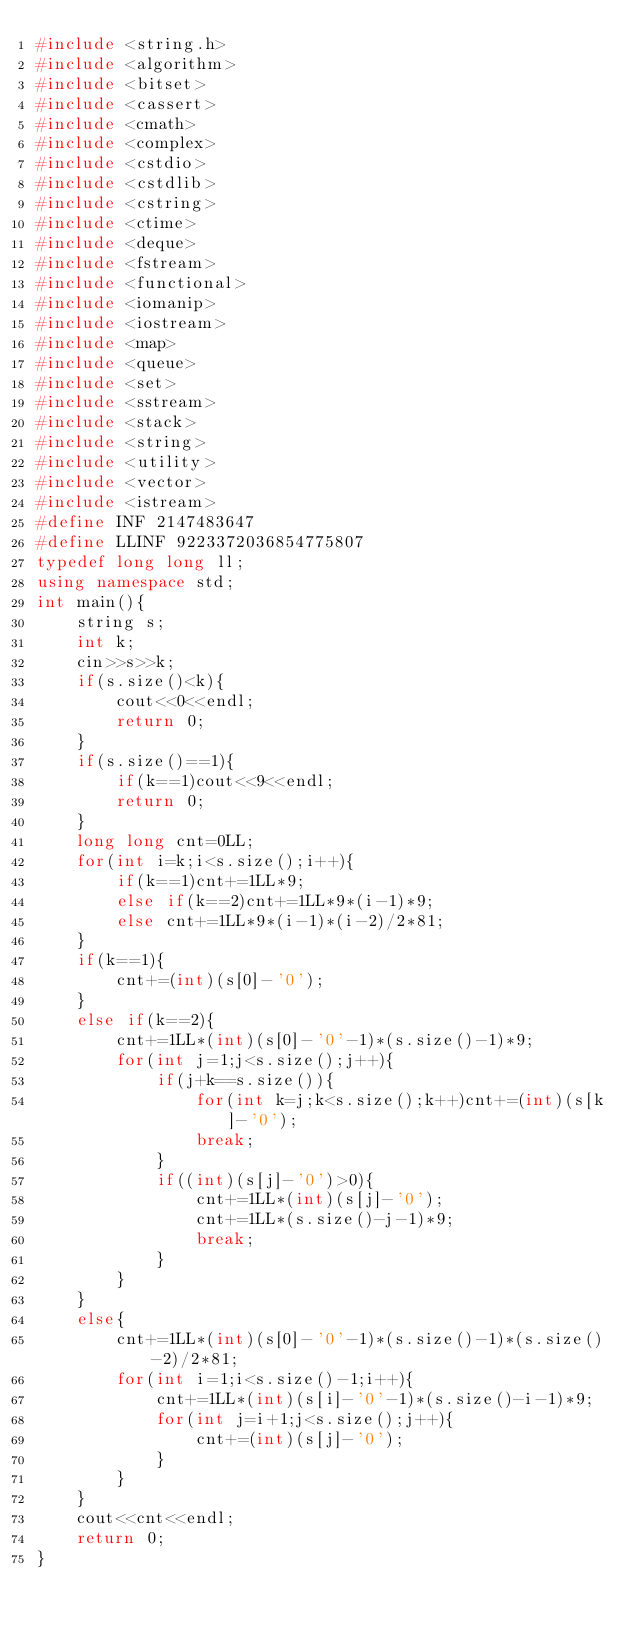Convert code to text. <code><loc_0><loc_0><loc_500><loc_500><_C++_>#include <string.h>
#include <algorithm>
#include <bitset>
#include <cassert>
#include <cmath>
#include <complex>
#include <cstdio>
#include <cstdlib>
#include <cstring>
#include <ctime>
#include <deque>
#include <fstream>
#include <functional>
#include <iomanip>
#include <iostream>
#include <map>
#include <queue>
#include <set>
#include <sstream>
#include <stack>
#include <string>
#include <utility>
#include <vector>
#include <istream>
#define INF 2147483647
#define LLINF 9223372036854775807
typedef long long ll;
using namespace std;
int main(){
	string s;
	int k;
	cin>>s>>k;
	if(s.size()<k){
		cout<<0<<endl;
		return 0;
	}
	if(s.size()==1){
		if(k==1)cout<<9<<endl;
		return 0;
	}
	long long cnt=0LL;
	for(int i=k;i<s.size();i++){
		if(k==1)cnt+=1LL*9;
		else if(k==2)cnt+=1LL*9*(i-1)*9;
		else cnt+=1LL*9*(i-1)*(i-2)/2*81;
	}
	if(k==1){
		cnt+=(int)(s[0]-'0');
	}
	else if(k==2){
		cnt+=1LL*(int)(s[0]-'0'-1)*(s.size()-1)*9;
		for(int j=1;j<s.size();j++){
			if(j+k==s.size()){
				for(int k=j;k<s.size();k++)cnt+=(int)(s[k]-'0');
				break;
			}
			if((int)(s[j]-'0')>0){
				cnt+=1LL*(int)(s[j]-'0');
				cnt+=1LL*(s.size()-j-1)*9;
				break;
			}
		}
	}
	else{
		cnt+=1LL*(int)(s[0]-'0'-1)*(s.size()-1)*(s.size()-2)/2*81;
		for(int i=1;i<s.size()-1;i++){
			cnt+=1LL*(int)(s[i]-'0'-1)*(s.size()-i-1)*9;
			for(int j=i+1;j<s.size();j++){
				cnt+=(int)(s[j]-'0');
			}
		}
	}
	cout<<cnt<<endl;
	return 0;
}</code> 